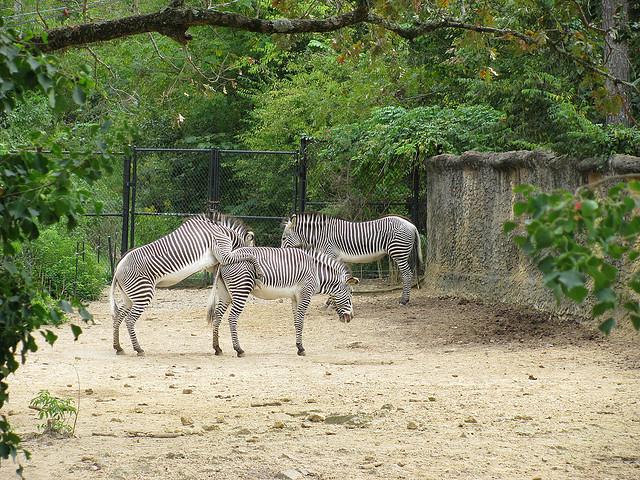Are there any palm trees pictured?
Quick response, please. No. What color is the sand?
Keep it brief. Tan. How many zebra are there?
Write a very short answer. 3. How many zebras are there?
Be succinct. 3. What are the zebras doing?
Answer briefly. Playing. How many animals can be seen?
Give a very brief answer. 3. Is there a fence behind the zebras?
Short answer required. Yes. Are the zebras in captivity?
Quick response, please. Yes. What color is the fence behind the zebras?
Be succinct. Black. Are the animals fighting?
Answer briefly. No. Is it a cow or a bull?
Quick response, please. Neither. 